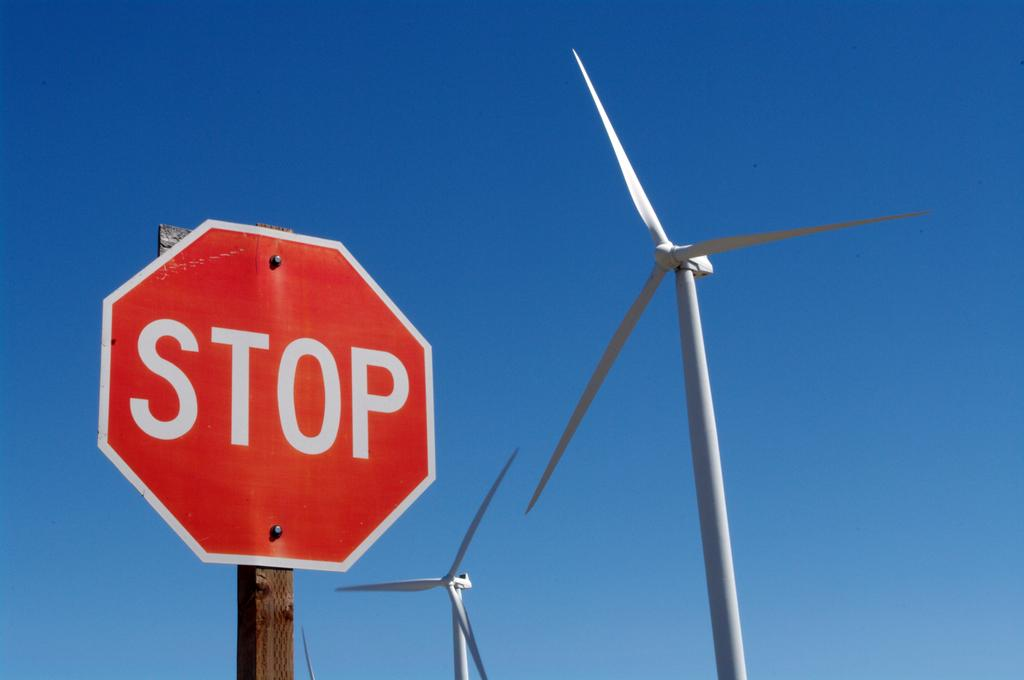Provide a one-sentence caption for the provided image. a STOP sign in front of two wind turbines. 